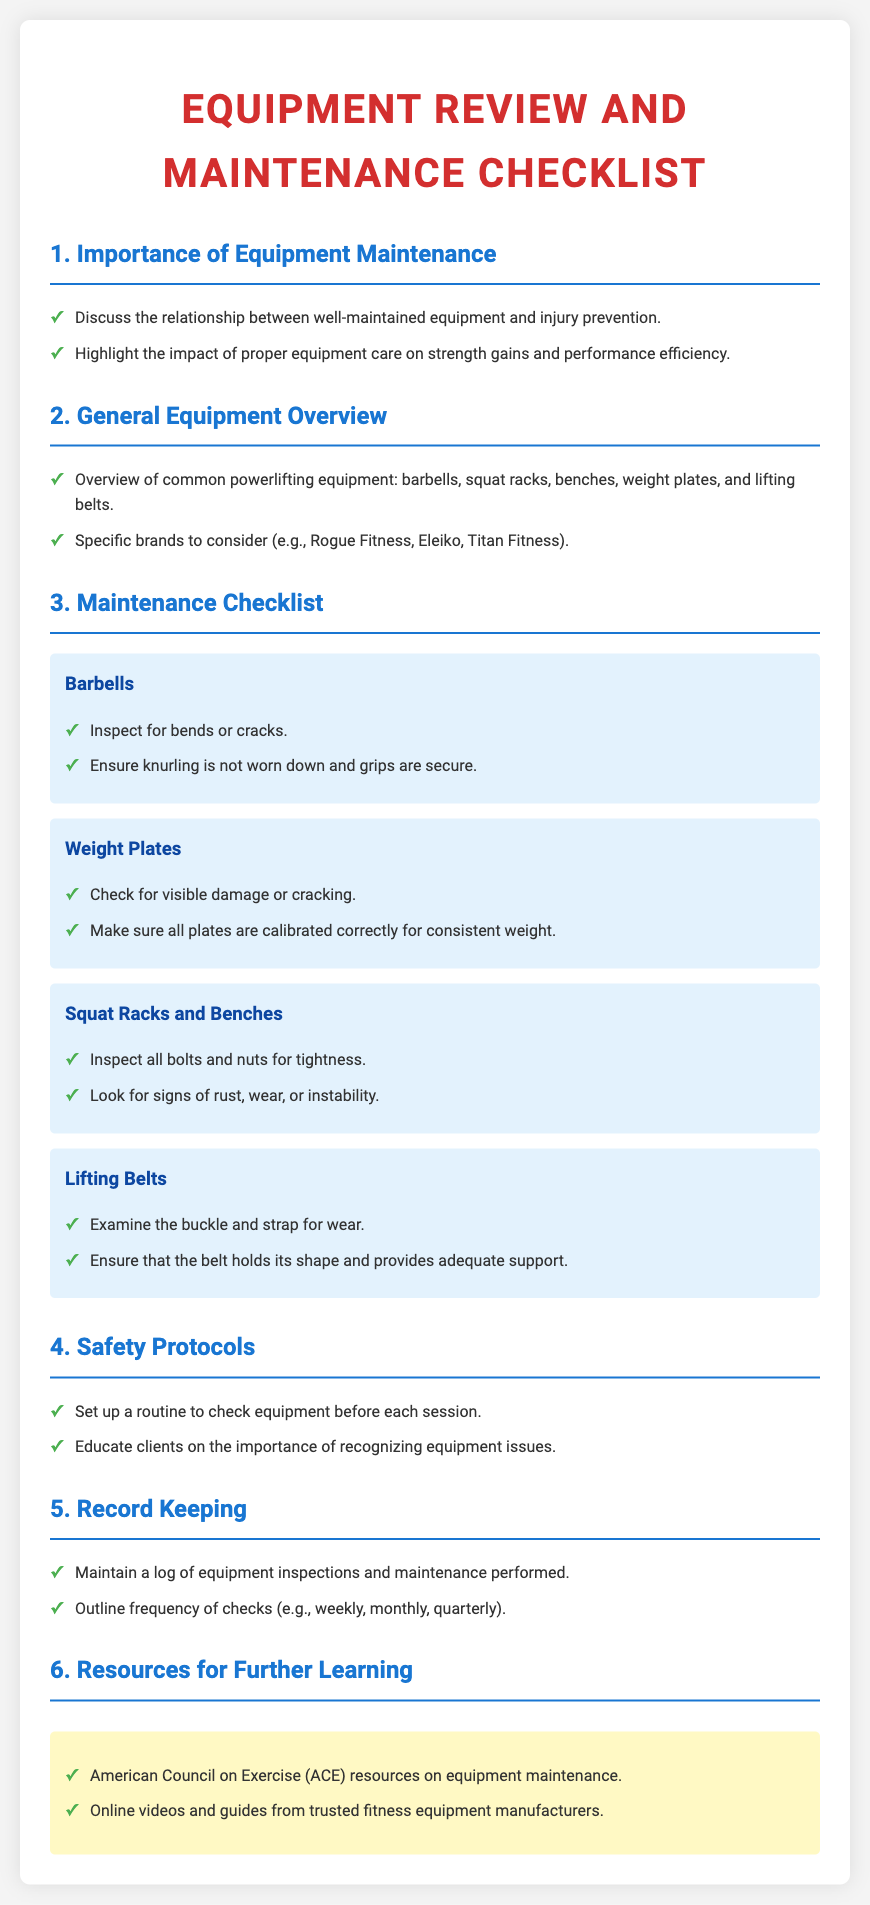What is the title of the document? The title is the main heading of the document, clearly stated at the top.
Answer: Equipment Review and Maintenance Checklist What are two common types of powerlifting equipment mentioned? The document lists various equipment types under the general overview section.
Answer: Barbells, squat racks How often should equipment checks be performed according to the frequency outline? The frequency of checks should be noted in the record keeping section of the document.
Answer: Weekly, monthly, quarterly What are two items listed in the maintenance checklist for barbells? The checklist highlights specific maintenance tasks that need to be completed for barbells.
Answer: Inspect for bends or cracks; Ensure knurling is not worn down Which organization is mentioned as a resource for further learning? The resources section identifies various organizations and platforms where additional information can be found.
Answer: American Council on Exercise What color are the maintenance items' background? The document specifies the visual design elements for the maintenance items to enhance clarity.
Answer: Light blue How does well-maintained equipment affect injury prevention? The document explains the connection between equipment maintenance and safety in the importance section.
Answer: Decreases risk What should clients be educated on regarding equipment? The safety protocols section emphasizes the importance of client education concerning equipment.
Answer: Recognizing equipment issues 